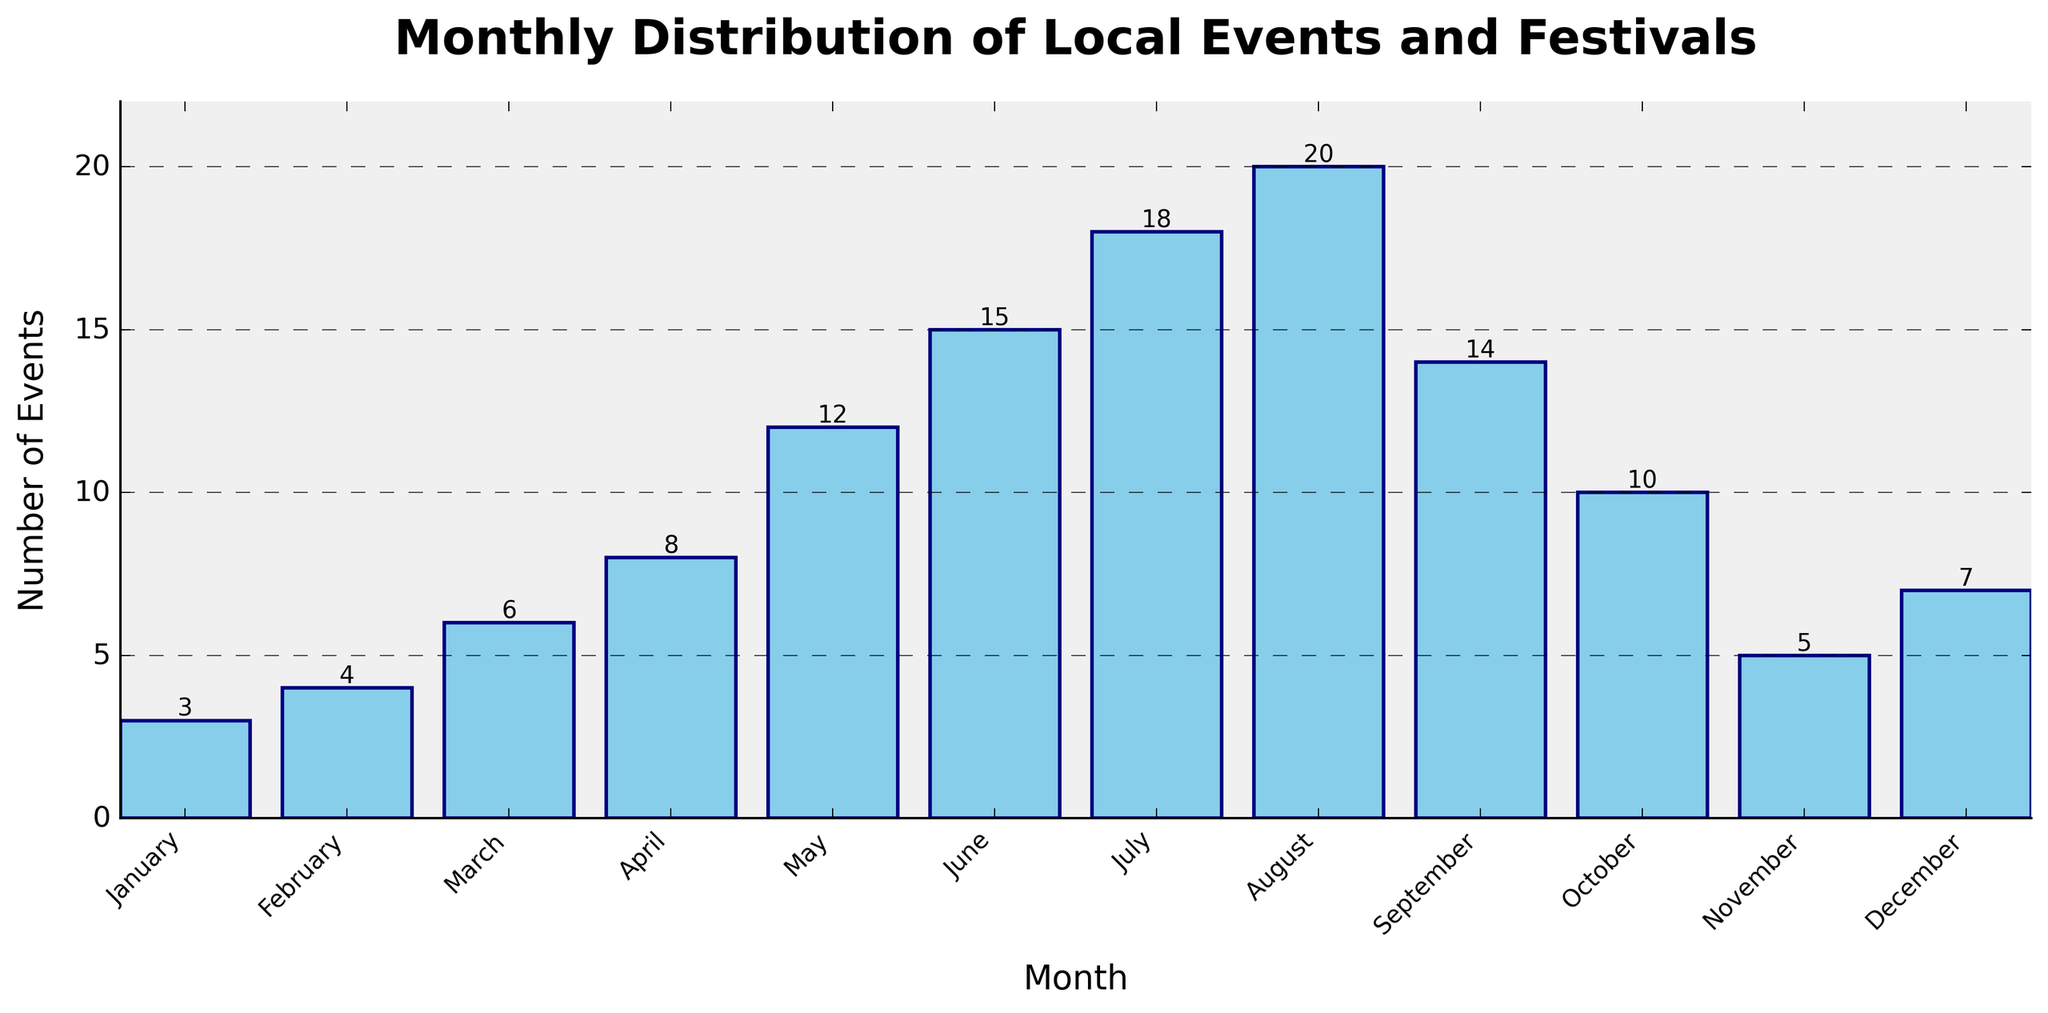What's the month with the highest number of events? Look at the bar that has the greatest height, which represents the number of events for each month. The highest bar is in August.
Answer: August Which month has fewer events, February or November? Compare the heights of the bars for February and November. February has a bar with a height of 4, while November has a bar with a height of 5.
Answer: February How many events happen in the first quarter of the year? Sum the number of events for January, February, and March: 3 (January) + 4 (February) + 6 (March) = 13.
Answer: 13 What is the total number of events held from June through August? Sum the number of events for June, July, and August: 15 (June) + 18 (July) + 20 (August) = 53.
Answer: 53 Does May have more events than April and March combined? Compare the number of events in May (12) with the sum of events in April and March (8 + 6 = 14). 12 is less than 14.
Answer: No What is the average number of events per month? Sum the total number of events for all months, then divide by 12 (total months): (3 + 4 + 6 + 8 + 12 + 15 + 18 + 20 + 14 + 10 + 5 + 7) / 12 = 122 / 12 ≈ 10.17
Answer: 10.17 Which month shows exactly double the number of events that are in January? Look for a bar with 6 events because January has 3 events and 3 * 2 = 6. This matches the number of events in March.
Answer: March What is the median number of events across all months? First, list the events in ascending order: (3, 4, 5, 6, 7, 8, 10, 12, 14, 15, 18, 20). With 12 data points, the median will be the average of the 6th and 7th data points: (8 + 10) / 2 = 9.
Answer: 9 Is the number of events in December less than the average for the year? The average number of events per month is approximately 10.17. December has 7 events, which is less than 10.17.
Answer: Yes 